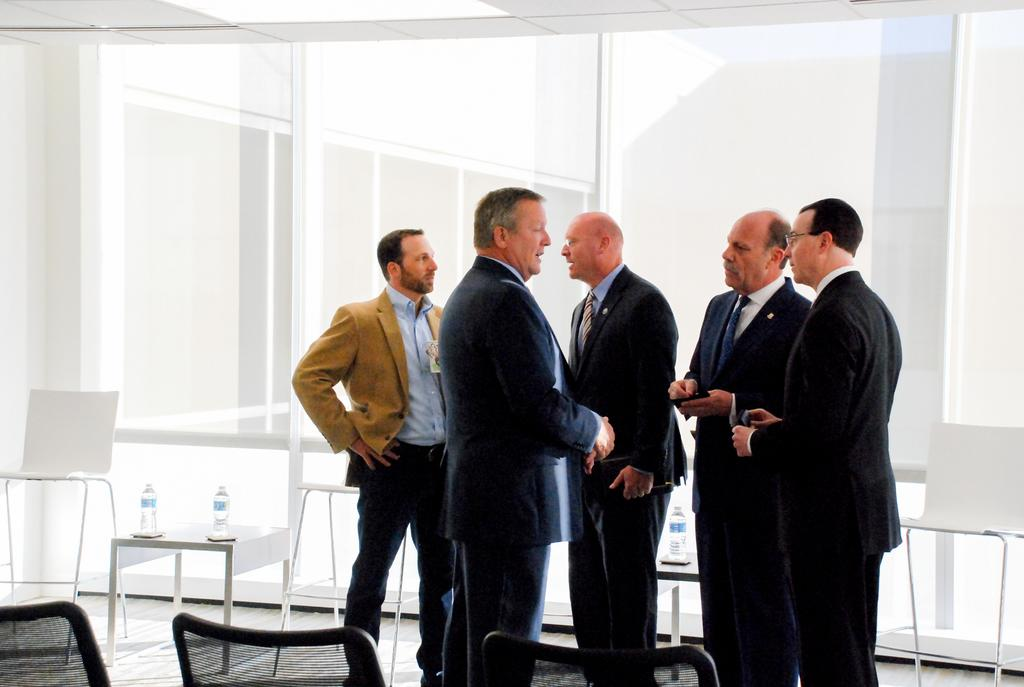How many people are in the image? There is a group of people standing in the image. What is present in the image besides the people? There is a table and a water bottle in the image. Are there any seating options visible in the image? Yes, there are chairs in the image. What type of root can be seen growing from the water bottle in the image? There is no root growing from the water bottle in the image. Can you describe the man standing in the image? There is no man specifically mentioned in the image; it only states that there is a group of people standing. 